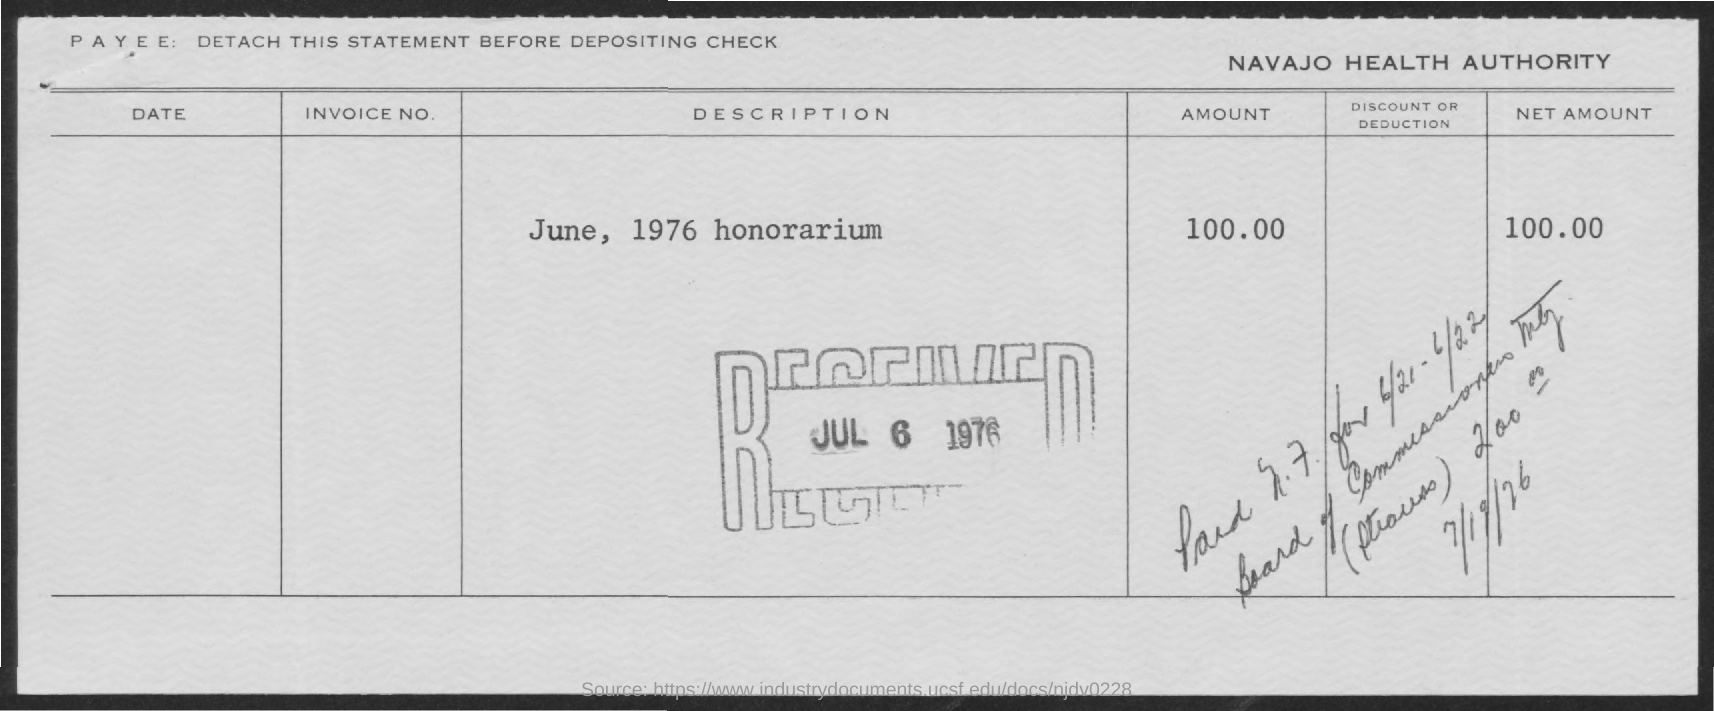What is the net amount of honorarium?
Provide a short and direct response. 100.00. What is the amount of honorarium?
Provide a succinct answer. $100.00. What is the name of health authority?
Your response must be concise. NAVAJO HEALTH AUTHORITY. On what date is honorarium dated?
Your response must be concise. JUNE, 1976. What date is honorarium received?
Offer a terse response. Jul 6 1976. 